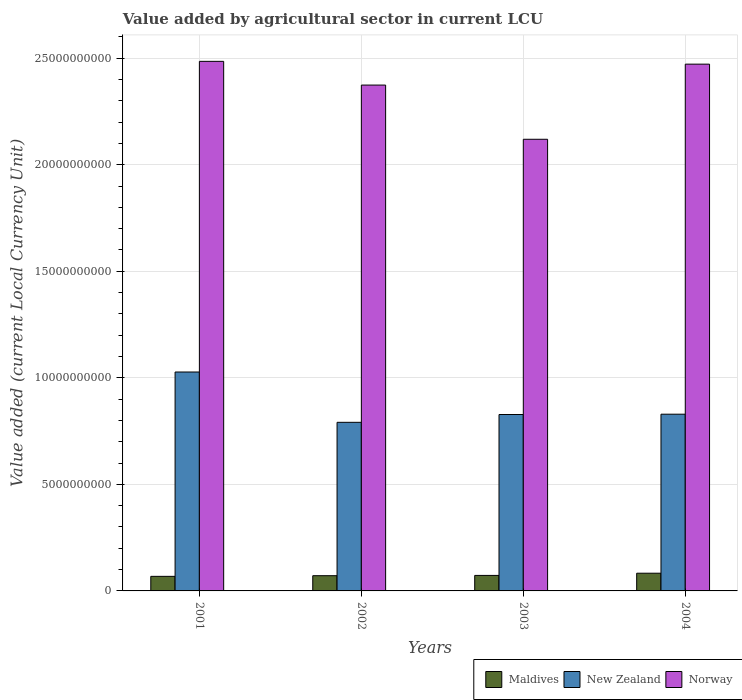Are the number of bars on each tick of the X-axis equal?
Offer a terse response. Yes. How many bars are there on the 1st tick from the right?
Offer a very short reply. 3. What is the label of the 1st group of bars from the left?
Your answer should be compact. 2001. What is the value added by agricultural sector in Norway in 2002?
Make the answer very short. 2.37e+1. Across all years, what is the maximum value added by agricultural sector in New Zealand?
Offer a very short reply. 1.03e+1. Across all years, what is the minimum value added by agricultural sector in Norway?
Ensure brevity in your answer.  2.12e+1. What is the total value added by agricultural sector in New Zealand in the graph?
Make the answer very short. 3.48e+1. What is the difference between the value added by agricultural sector in Maldives in 2002 and that in 2003?
Provide a succinct answer. -1.27e+07. What is the difference between the value added by agricultural sector in New Zealand in 2003 and the value added by agricultural sector in Maldives in 2004?
Provide a succinct answer. 7.45e+09. What is the average value added by agricultural sector in Norway per year?
Your answer should be compact. 2.36e+1. In the year 2003, what is the difference between the value added by agricultural sector in Maldives and value added by agricultural sector in Norway?
Make the answer very short. -2.05e+1. What is the ratio of the value added by agricultural sector in Maldives in 2002 to that in 2004?
Keep it short and to the point. 0.86. What is the difference between the highest and the second highest value added by agricultural sector in Norway?
Give a very brief answer. 1.31e+08. What is the difference between the highest and the lowest value added by agricultural sector in Norway?
Offer a terse response. 3.66e+09. Is the sum of the value added by agricultural sector in New Zealand in 2003 and 2004 greater than the maximum value added by agricultural sector in Maldives across all years?
Make the answer very short. Yes. What does the 1st bar from the left in 2002 represents?
Your answer should be very brief. Maldives. What does the 2nd bar from the right in 2003 represents?
Keep it short and to the point. New Zealand. Is it the case that in every year, the sum of the value added by agricultural sector in New Zealand and value added by agricultural sector in Norway is greater than the value added by agricultural sector in Maldives?
Ensure brevity in your answer.  Yes. How many bars are there?
Provide a succinct answer. 12. Are all the bars in the graph horizontal?
Your response must be concise. No. What is the difference between two consecutive major ticks on the Y-axis?
Offer a terse response. 5.00e+09. Are the values on the major ticks of Y-axis written in scientific E-notation?
Make the answer very short. No. Does the graph contain grids?
Your response must be concise. Yes. Where does the legend appear in the graph?
Your answer should be very brief. Bottom right. How many legend labels are there?
Provide a short and direct response. 3. How are the legend labels stacked?
Give a very brief answer. Horizontal. What is the title of the graph?
Keep it short and to the point. Value added by agricultural sector in current LCU. What is the label or title of the X-axis?
Your answer should be very brief. Years. What is the label or title of the Y-axis?
Keep it short and to the point. Value added (current Local Currency Unit). What is the Value added (current Local Currency Unit) of Maldives in 2001?
Make the answer very short. 6.84e+08. What is the Value added (current Local Currency Unit) in New Zealand in 2001?
Your answer should be compact. 1.03e+1. What is the Value added (current Local Currency Unit) of Norway in 2001?
Offer a terse response. 2.49e+1. What is the Value added (current Local Currency Unit) in Maldives in 2002?
Ensure brevity in your answer.  7.15e+08. What is the Value added (current Local Currency Unit) of New Zealand in 2002?
Offer a very short reply. 7.91e+09. What is the Value added (current Local Currency Unit) of Norway in 2002?
Offer a very short reply. 2.37e+1. What is the Value added (current Local Currency Unit) of Maldives in 2003?
Ensure brevity in your answer.  7.27e+08. What is the Value added (current Local Currency Unit) in New Zealand in 2003?
Your answer should be very brief. 8.28e+09. What is the Value added (current Local Currency Unit) of Norway in 2003?
Provide a short and direct response. 2.12e+1. What is the Value added (current Local Currency Unit) of Maldives in 2004?
Your answer should be compact. 8.31e+08. What is the Value added (current Local Currency Unit) of New Zealand in 2004?
Provide a short and direct response. 8.29e+09. What is the Value added (current Local Currency Unit) of Norway in 2004?
Give a very brief answer. 2.47e+1. Across all years, what is the maximum Value added (current Local Currency Unit) of Maldives?
Offer a very short reply. 8.31e+08. Across all years, what is the maximum Value added (current Local Currency Unit) in New Zealand?
Your answer should be very brief. 1.03e+1. Across all years, what is the maximum Value added (current Local Currency Unit) in Norway?
Offer a very short reply. 2.49e+1. Across all years, what is the minimum Value added (current Local Currency Unit) of Maldives?
Make the answer very short. 6.84e+08. Across all years, what is the minimum Value added (current Local Currency Unit) in New Zealand?
Keep it short and to the point. 7.91e+09. Across all years, what is the minimum Value added (current Local Currency Unit) in Norway?
Keep it short and to the point. 2.12e+1. What is the total Value added (current Local Currency Unit) of Maldives in the graph?
Provide a succinct answer. 2.96e+09. What is the total Value added (current Local Currency Unit) of New Zealand in the graph?
Your response must be concise. 3.48e+1. What is the total Value added (current Local Currency Unit) of Norway in the graph?
Make the answer very short. 9.45e+1. What is the difference between the Value added (current Local Currency Unit) in Maldives in 2001 and that in 2002?
Your answer should be very brief. -3.09e+07. What is the difference between the Value added (current Local Currency Unit) in New Zealand in 2001 and that in 2002?
Provide a succinct answer. 2.36e+09. What is the difference between the Value added (current Local Currency Unit) of Norway in 2001 and that in 2002?
Your answer should be very brief. 1.11e+09. What is the difference between the Value added (current Local Currency Unit) of Maldives in 2001 and that in 2003?
Give a very brief answer. -4.37e+07. What is the difference between the Value added (current Local Currency Unit) in New Zealand in 2001 and that in 2003?
Your response must be concise. 1.99e+09. What is the difference between the Value added (current Local Currency Unit) in Norway in 2001 and that in 2003?
Keep it short and to the point. 3.66e+09. What is the difference between the Value added (current Local Currency Unit) of Maldives in 2001 and that in 2004?
Ensure brevity in your answer.  -1.47e+08. What is the difference between the Value added (current Local Currency Unit) of New Zealand in 2001 and that in 2004?
Your answer should be compact. 1.98e+09. What is the difference between the Value added (current Local Currency Unit) of Norway in 2001 and that in 2004?
Make the answer very short. 1.31e+08. What is the difference between the Value added (current Local Currency Unit) of Maldives in 2002 and that in 2003?
Offer a very short reply. -1.27e+07. What is the difference between the Value added (current Local Currency Unit) of New Zealand in 2002 and that in 2003?
Provide a short and direct response. -3.66e+08. What is the difference between the Value added (current Local Currency Unit) in Norway in 2002 and that in 2003?
Keep it short and to the point. 2.54e+09. What is the difference between the Value added (current Local Currency Unit) of Maldives in 2002 and that in 2004?
Give a very brief answer. -1.16e+08. What is the difference between the Value added (current Local Currency Unit) of New Zealand in 2002 and that in 2004?
Offer a terse response. -3.81e+08. What is the difference between the Value added (current Local Currency Unit) of Norway in 2002 and that in 2004?
Offer a very short reply. -9.82e+08. What is the difference between the Value added (current Local Currency Unit) in Maldives in 2003 and that in 2004?
Offer a very short reply. -1.04e+08. What is the difference between the Value added (current Local Currency Unit) of New Zealand in 2003 and that in 2004?
Provide a short and direct response. -1.48e+07. What is the difference between the Value added (current Local Currency Unit) of Norway in 2003 and that in 2004?
Offer a terse response. -3.53e+09. What is the difference between the Value added (current Local Currency Unit) in Maldives in 2001 and the Value added (current Local Currency Unit) in New Zealand in 2002?
Your response must be concise. -7.23e+09. What is the difference between the Value added (current Local Currency Unit) in Maldives in 2001 and the Value added (current Local Currency Unit) in Norway in 2002?
Provide a succinct answer. -2.31e+1. What is the difference between the Value added (current Local Currency Unit) of New Zealand in 2001 and the Value added (current Local Currency Unit) of Norway in 2002?
Your response must be concise. -1.35e+1. What is the difference between the Value added (current Local Currency Unit) in Maldives in 2001 and the Value added (current Local Currency Unit) in New Zealand in 2003?
Ensure brevity in your answer.  -7.59e+09. What is the difference between the Value added (current Local Currency Unit) of Maldives in 2001 and the Value added (current Local Currency Unit) of Norway in 2003?
Make the answer very short. -2.05e+1. What is the difference between the Value added (current Local Currency Unit) in New Zealand in 2001 and the Value added (current Local Currency Unit) in Norway in 2003?
Ensure brevity in your answer.  -1.09e+1. What is the difference between the Value added (current Local Currency Unit) in Maldives in 2001 and the Value added (current Local Currency Unit) in New Zealand in 2004?
Your answer should be very brief. -7.61e+09. What is the difference between the Value added (current Local Currency Unit) of Maldives in 2001 and the Value added (current Local Currency Unit) of Norway in 2004?
Provide a succinct answer. -2.40e+1. What is the difference between the Value added (current Local Currency Unit) of New Zealand in 2001 and the Value added (current Local Currency Unit) of Norway in 2004?
Ensure brevity in your answer.  -1.44e+1. What is the difference between the Value added (current Local Currency Unit) in Maldives in 2002 and the Value added (current Local Currency Unit) in New Zealand in 2003?
Ensure brevity in your answer.  -7.56e+09. What is the difference between the Value added (current Local Currency Unit) of Maldives in 2002 and the Value added (current Local Currency Unit) of Norway in 2003?
Ensure brevity in your answer.  -2.05e+1. What is the difference between the Value added (current Local Currency Unit) of New Zealand in 2002 and the Value added (current Local Currency Unit) of Norway in 2003?
Your response must be concise. -1.33e+1. What is the difference between the Value added (current Local Currency Unit) in Maldives in 2002 and the Value added (current Local Currency Unit) in New Zealand in 2004?
Your answer should be very brief. -7.58e+09. What is the difference between the Value added (current Local Currency Unit) in Maldives in 2002 and the Value added (current Local Currency Unit) in Norway in 2004?
Ensure brevity in your answer.  -2.40e+1. What is the difference between the Value added (current Local Currency Unit) of New Zealand in 2002 and the Value added (current Local Currency Unit) of Norway in 2004?
Your response must be concise. -1.68e+1. What is the difference between the Value added (current Local Currency Unit) of Maldives in 2003 and the Value added (current Local Currency Unit) of New Zealand in 2004?
Your response must be concise. -7.57e+09. What is the difference between the Value added (current Local Currency Unit) in Maldives in 2003 and the Value added (current Local Currency Unit) in Norway in 2004?
Your response must be concise. -2.40e+1. What is the difference between the Value added (current Local Currency Unit) of New Zealand in 2003 and the Value added (current Local Currency Unit) of Norway in 2004?
Provide a succinct answer. -1.64e+1. What is the average Value added (current Local Currency Unit) in Maldives per year?
Your answer should be compact. 7.39e+08. What is the average Value added (current Local Currency Unit) of New Zealand per year?
Offer a terse response. 8.69e+09. What is the average Value added (current Local Currency Unit) of Norway per year?
Offer a terse response. 2.36e+1. In the year 2001, what is the difference between the Value added (current Local Currency Unit) in Maldives and Value added (current Local Currency Unit) in New Zealand?
Your answer should be compact. -9.59e+09. In the year 2001, what is the difference between the Value added (current Local Currency Unit) of Maldives and Value added (current Local Currency Unit) of Norway?
Give a very brief answer. -2.42e+1. In the year 2001, what is the difference between the Value added (current Local Currency Unit) of New Zealand and Value added (current Local Currency Unit) of Norway?
Provide a short and direct response. -1.46e+1. In the year 2002, what is the difference between the Value added (current Local Currency Unit) of Maldives and Value added (current Local Currency Unit) of New Zealand?
Your answer should be compact. -7.20e+09. In the year 2002, what is the difference between the Value added (current Local Currency Unit) in Maldives and Value added (current Local Currency Unit) in Norway?
Provide a short and direct response. -2.30e+1. In the year 2002, what is the difference between the Value added (current Local Currency Unit) in New Zealand and Value added (current Local Currency Unit) in Norway?
Give a very brief answer. -1.58e+1. In the year 2003, what is the difference between the Value added (current Local Currency Unit) of Maldives and Value added (current Local Currency Unit) of New Zealand?
Ensure brevity in your answer.  -7.55e+09. In the year 2003, what is the difference between the Value added (current Local Currency Unit) of Maldives and Value added (current Local Currency Unit) of Norway?
Your response must be concise. -2.05e+1. In the year 2003, what is the difference between the Value added (current Local Currency Unit) of New Zealand and Value added (current Local Currency Unit) of Norway?
Your response must be concise. -1.29e+1. In the year 2004, what is the difference between the Value added (current Local Currency Unit) in Maldives and Value added (current Local Currency Unit) in New Zealand?
Your answer should be compact. -7.46e+09. In the year 2004, what is the difference between the Value added (current Local Currency Unit) of Maldives and Value added (current Local Currency Unit) of Norway?
Make the answer very short. -2.39e+1. In the year 2004, what is the difference between the Value added (current Local Currency Unit) in New Zealand and Value added (current Local Currency Unit) in Norway?
Ensure brevity in your answer.  -1.64e+1. What is the ratio of the Value added (current Local Currency Unit) of Maldives in 2001 to that in 2002?
Give a very brief answer. 0.96. What is the ratio of the Value added (current Local Currency Unit) of New Zealand in 2001 to that in 2002?
Offer a very short reply. 1.3. What is the ratio of the Value added (current Local Currency Unit) of Norway in 2001 to that in 2002?
Keep it short and to the point. 1.05. What is the ratio of the Value added (current Local Currency Unit) in Maldives in 2001 to that in 2003?
Provide a succinct answer. 0.94. What is the ratio of the Value added (current Local Currency Unit) of New Zealand in 2001 to that in 2003?
Provide a succinct answer. 1.24. What is the ratio of the Value added (current Local Currency Unit) of Norway in 2001 to that in 2003?
Provide a succinct answer. 1.17. What is the ratio of the Value added (current Local Currency Unit) of Maldives in 2001 to that in 2004?
Provide a short and direct response. 0.82. What is the ratio of the Value added (current Local Currency Unit) in New Zealand in 2001 to that in 2004?
Offer a very short reply. 1.24. What is the ratio of the Value added (current Local Currency Unit) of Norway in 2001 to that in 2004?
Give a very brief answer. 1.01. What is the ratio of the Value added (current Local Currency Unit) in Maldives in 2002 to that in 2003?
Make the answer very short. 0.98. What is the ratio of the Value added (current Local Currency Unit) of New Zealand in 2002 to that in 2003?
Offer a terse response. 0.96. What is the ratio of the Value added (current Local Currency Unit) of Norway in 2002 to that in 2003?
Your answer should be very brief. 1.12. What is the ratio of the Value added (current Local Currency Unit) in Maldives in 2002 to that in 2004?
Your response must be concise. 0.86. What is the ratio of the Value added (current Local Currency Unit) of New Zealand in 2002 to that in 2004?
Provide a short and direct response. 0.95. What is the ratio of the Value added (current Local Currency Unit) of Norway in 2002 to that in 2004?
Your answer should be compact. 0.96. What is the ratio of the Value added (current Local Currency Unit) of Maldives in 2003 to that in 2004?
Offer a very short reply. 0.88. What is the ratio of the Value added (current Local Currency Unit) of New Zealand in 2003 to that in 2004?
Offer a terse response. 1. What is the ratio of the Value added (current Local Currency Unit) in Norway in 2003 to that in 2004?
Ensure brevity in your answer.  0.86. What is the difference between the highest and the second highest Value added (current Local Currency Unit) of Maldives?
Your answer should be very brief. 1.04e+08. What is the difference between the highest and the second highest Value added (current Local Currency Unit) in New Zealand?
Keep it short and to the point. 1.98e+09. What is the difference between the highest and the second highest Value added (current Local Currency Unit) in Norway?
Provide a short and direct response. 1.31e+08. What is the difference between the highest and the lowest Value added (current Local Currency Unit) in Maldives?
Make the answer very short. 1.47e+08. What is the difference between the highest and the lowest Value added (current Local Currency Unit) in New Zealand?
Your response must be concise. 2.36e+09. What is the difference between the highest and the lowest Value added (current Local Currency Unit) of Norway?
Provide a short and direct response. 3.66e+09. 